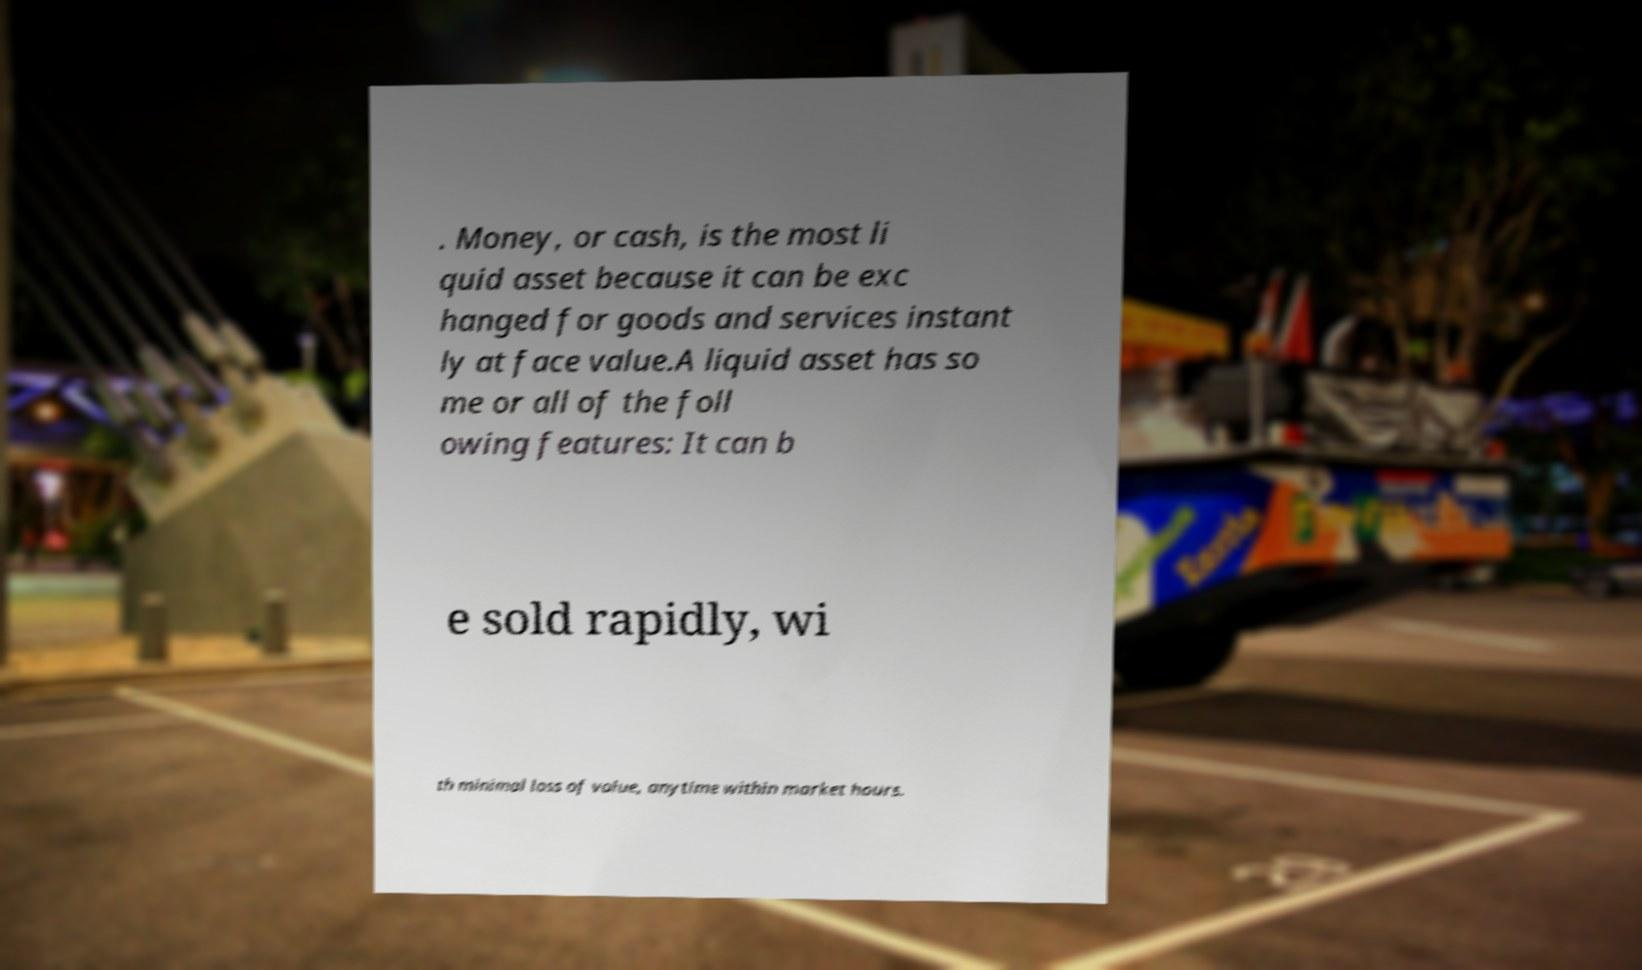Please read and relay the text visible in this image. What does it say? . Money, or cash, is the most li quid asset because it can be exc hanged for goods and services instant ly at face value.A liquid asset has so me or all of the foll owing features: It can b e sold rapidly, wi th minimal loss of value, anytime within market hours. 